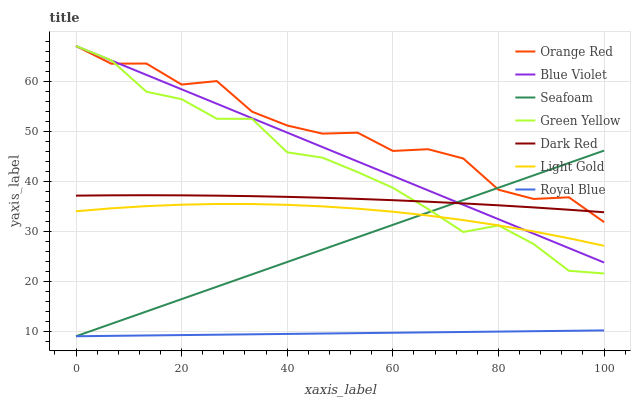Does Royal Blue have the minimum area under the curve?
Answer yes or no. Yes. Does Orange Red have the maximum area under the curve?
Answer yes or no. Yes. Does Seafoam have the minimum area under the curve?
Answer yes or no. No. Does Seafoam have the maximum area under the curve?
Answer yes or no. No. Is Royal Blue the smoothest?
Answer yes or no. Yes. Is Orange Red the roughest?
Answer yes or no. Yes. Is Seafoam the smoothest?
Answer yes or no. No. Is Seafoam the roughest?
Answer yes or no. No. Does Seafoam have the lowest value?
Answer yes or no. Yes. Does Green Yellow have the lowest value?
Answer yes or no. No. Does Blue Violet have the highest value?
Answer yes or no. Yes. Does Seafoam have the highest value?
Answer yes or no. No. Is Light Gold less than Dark Red?
Answer yes or no. Yes. Is Green Yellow greater than Royal Blue?
Answer yes or no. Yes. Does Dark Red intersect Blue Violet?
Answer yes or no. Yes. Is Dark Red less than Blue Violet?
Answer yes or no. No. Is Dark Red greater than Blue Violet?
Answer yes or no. No. Does Light Gold intersect Dark Red?
Answer yes or no. No. 